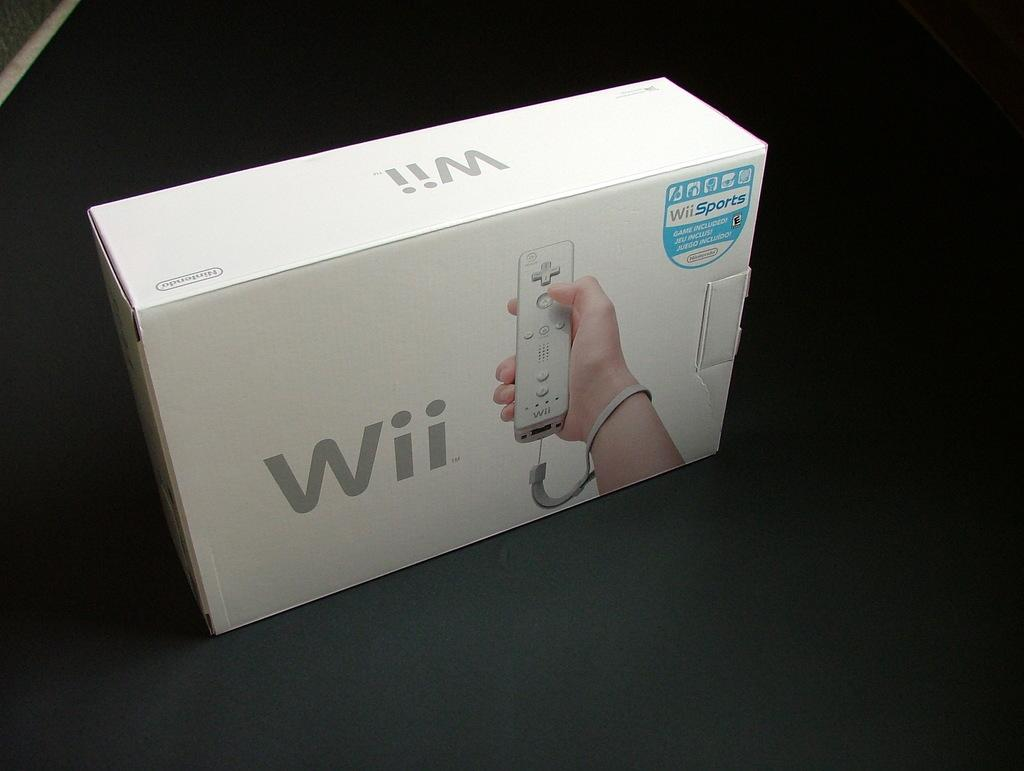<image>
Offer a succinct explanation of the picture presented. An original Wii box that has the game wiisports included. 